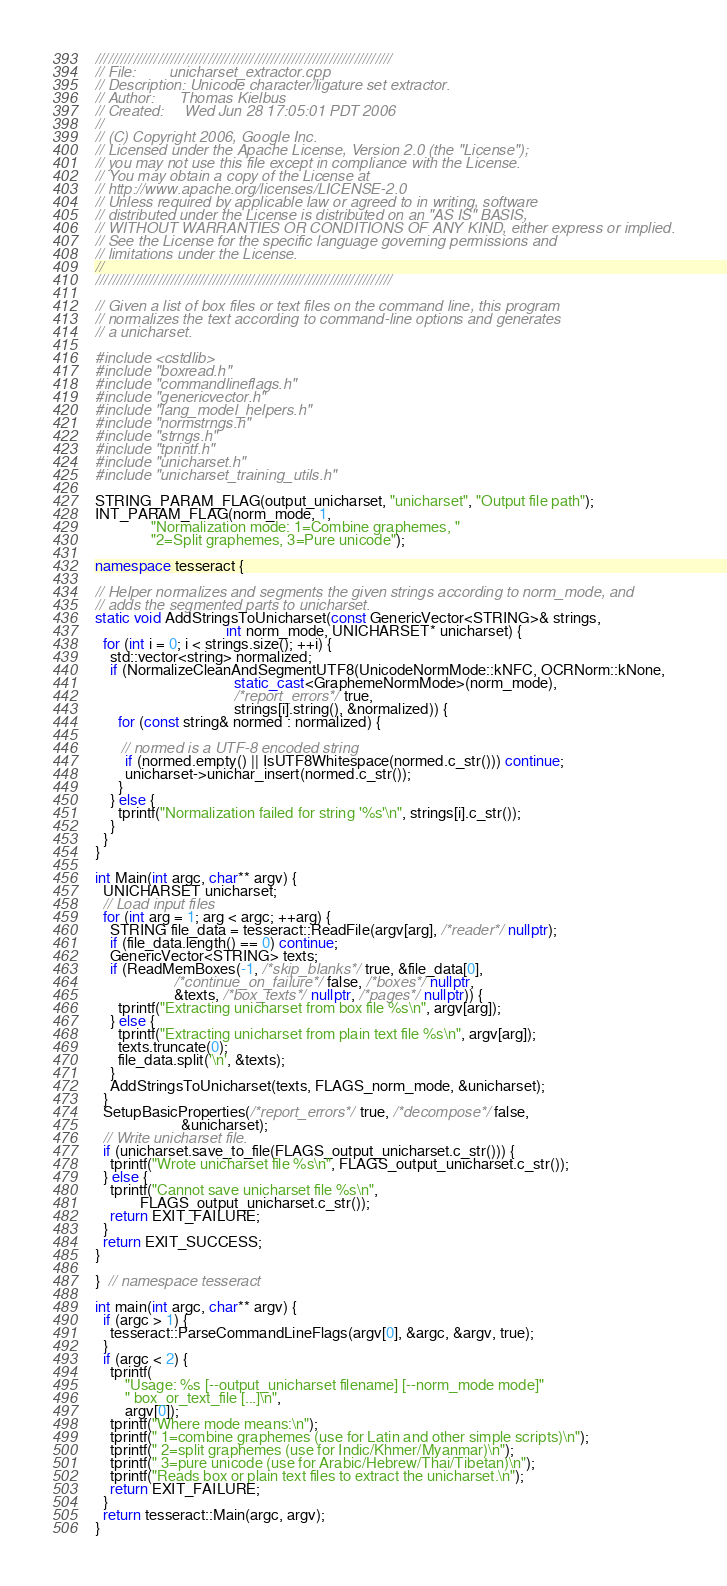<code> <loc_0><loc_0><loc_500><loc_500><_C++_>///////////////////////////////////////////////////////////////////////
// File:        unicharset_extractor.cpp
// Description: Unicode character/ligature set extractor.
// Author:      Thomas Kielbus
// Created:     Wed Jun 28 17:05:01 PDT 2006
//
// (C) Copyright 2006, Google Inc.
// Licensed under the Apache License, Version 2.0 (the "License");
// you may not use this file except in compliance with the License.
// You may obtain a copy of the License at
// http://www.apache.org/licenses/LICENSE-2.0
// Unless required by applicable law or agreed to in writing, software
// distributed under the License is distributed on an "AS IS" BASIS,
// WITHOUT WARRANTIES OR CONDITIONS OF ANY KIND, either express or implied.
// See the License for the specific language governing permissions and
// limitations under the License.
//
///////////////////////////////////////////////////////////////////////

// Given a list of box files or text files on the command line, this program
// normalizes the text according to command-line options and generates
// a unicharset.

#include <cstdlib>
#include "boxread.h"
#include "commandlineflags.h"
#include "genericvector.h"
#include "lang_model_helpers.h"
#include "normstrngs.h"
#include "strngs.h"
#include "tprintf.h"
#include "unicharset.h"
#include "unicharset_training_utils.h"

STRING_PARAM_FLAG(output_unicharset, "unicharset", "Output file path");
INT_PARAM_FLAG(norm_mode, 1,
               "Normalization mode: 1=Combine graphemes, "
               "2=Split graphemes, 3=Pure unicode");

namespace tesseract {

// Helper normalizes and segments the given strings according to norm_mode, and
// adds the segmented parts to unicharset.
static void AddStringsToUnicharset(const GenericVector<STRING>& strings,
                                   int norm_mode, UNICHARSET* unicharset) {
  for (int i = 0; i < strings.size(); ++i) {
    std::vector<string> normalized;
    if (NormalizeCleanAndSegmentUTF8(UnicodeNormMode::kNFC, OCRNorm::kNone,
                                     static_cast<GraphemeNormMode>(norm_mode),
                                     /*report_errors*/ true,
                                     strings[i].string(), &normalized)) {
      for (const string& normed : normalized) {

       // normed is a UTF-8 encoded string
        if (normed.empty() || IsUTF8Whitespace(normed.c_str())) continue;
        unicharset->unichar_insert(normed.c_str());
      }
    } else {
      tprintf("Normalization failed for string '%s'\n", strings[i].c_str());
    }
  }
}

int Main(int argc, char** argv) {
  UNICHARSET unicharset;
  // Load input files
  for (int arg = 1; arg < argc; ++arg) {
    STRING file_data = tesseract::ReadFile(argv[arg], /*reader*/ nullptr);
    if (file_data.length() == 0) continue;
    GenericVector<STRING> texts;
    if (ReadMemBoxes(-1, /*skip_blanks*/ true, &file_data[0],
                     /*continue_on_failure*/ false, /*boxes*/ nullptr,
                     &texts, /*box_texts*/ nullptr, /*pages*/ nullptr)) {
      tprintf("Extracting unicharset from box file %s\n", argv[arg]);
    } else {
      tprintf("Extracting unicharset from plain text file %s\n", argv[arg]);
      texts.truncate(0);
      file_data.split('\n', &texts);
    }
    AddStringsToUnicharset(texts, FLAGS_norm_mode, &unicharset);
  }
  SetupBasicProperties(/*report_errors*/ true, /*decompose*/ false,
                       &unicharset);
  // Write unicharset file.
  if (unicharset.save_to_file(FLAGS_output_unicharset.c_str())) {
    tprintf("Wrote unicharset file %s\n", FLAGS_output_unicharset.c_str());
  } else {
    tprintf("Cannot save unicharset file %s\n",
            FLAGS_output_unicharset.c_str());
    return EXIT_FAILURE;
  }
  return EXIT_SUCCESS;
}

}  // namespace tesseract

int main(int argc, char** argv) {
  if (argc > 1) {
    tesseract::ParseCommandLineFlags(argv[0], &argc, &argv, true);
  }
  if (argc < 2) {
    tprintf(
        "Usage: %s [--output_unicharset filename] [--norm_mode mode]"
        " box_or_text_file [...]\n",
        argv[0]);
    tprintf("Where mode means:\n");
    tprintf(" 1=combine graphemes (use for Latin and other simple scripts)\n");
    tprintf(" 2=split graphemes (use for Indic/Khmer/Myanmar)\n");
    tprintf(" 3=pure unicode (use for Arabic/Hebrew/Thai/Tibetan)\n");
    tprintf("Reads box or plain text files to extract the unicharset.\n");
    return EXIT_FAILURE;
  }
  return tesseract::Main(argc, argv);
}
</code> 